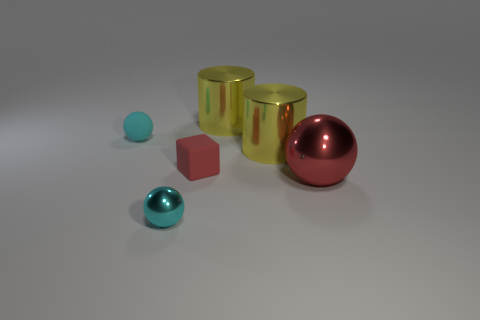Do the shiny sphere to the left of the red block and the tiny cube have the same size?
Provide a short and direct response. Yes. How many other things are the same material as the tiny red cube?
Ensure brevity in your answer.  1. Is the number of cyan metal things greater than the number of small purple metal spheres?
Make the answer very short. Yes. There is a ball in front of the big shiny sphere in front of the cyan ball behind the large red thing; what is it made of?
Offer a very short reply. Metal. Is the big metal ball the same color as the matte sphere?
Give a very brief answer. No. Is there a big metal sphere of the same color as the small metallic sphere?
Keep it short and to the point. No. The other cyan object that is the same size as the cyan rubber object is what shape?
Your answer should be very brief. Sphere. Are there fewer yellow cylinders than large metal objects?
Keep it short and to the point. Yes. What number of brown matte cubes are the same size as the cyan rubber thing?
Keep it short and to the point. 0. What shape is the big metal object that is the same color as the block?
Provide a succinct answer. Sphere. 